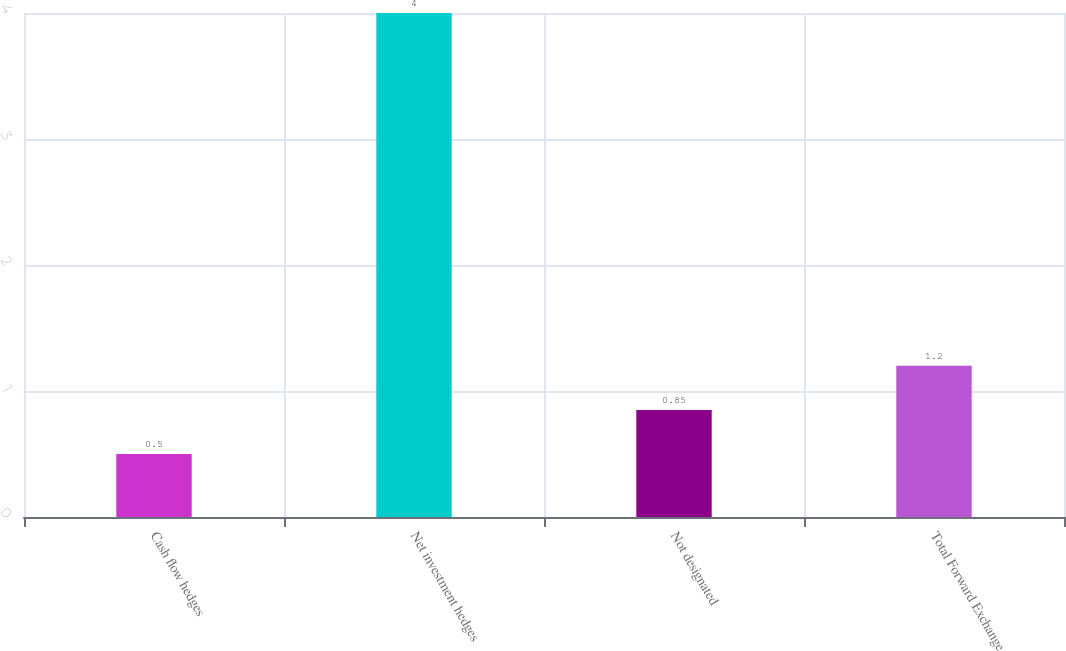Convert chart to OTSL. <chart><loc_0><loc_0><loc_500><loc_500><bar_chart><fcel>Cash flow hedges<fcel>Net investment hedges<fcel>Not designated<fcel>Total Forward Exchange<nl><fcel>0.5<fcel>4<fcel>0.85<fcel>1.2<nl></chart> 